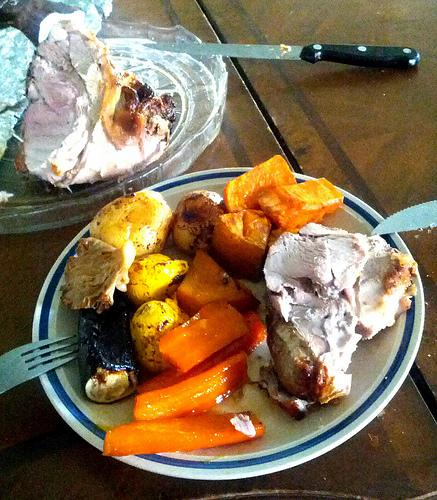Question: what is on the plate?
Choices:
A. Food.
B. Salad.
C. Pizza.
D. Taco.
Answer with the letter. Answer: A Question: how many knives are there?
Choices:
A. Three.
B. Six.
C. Two.
D. Nine.
Answer with the letter. Answer: C Question: what color are the carrots?
Choices:
A. Orange.
B. Green.
C. White.
D. Purple.
Answer with the letter. Answer: A Question: what vegetable is on the plate?
Choices:
A. Yams.
B. Broccoli.
C. Cauliflower.
D. Peas.
Answer with the letter. Answer: A 